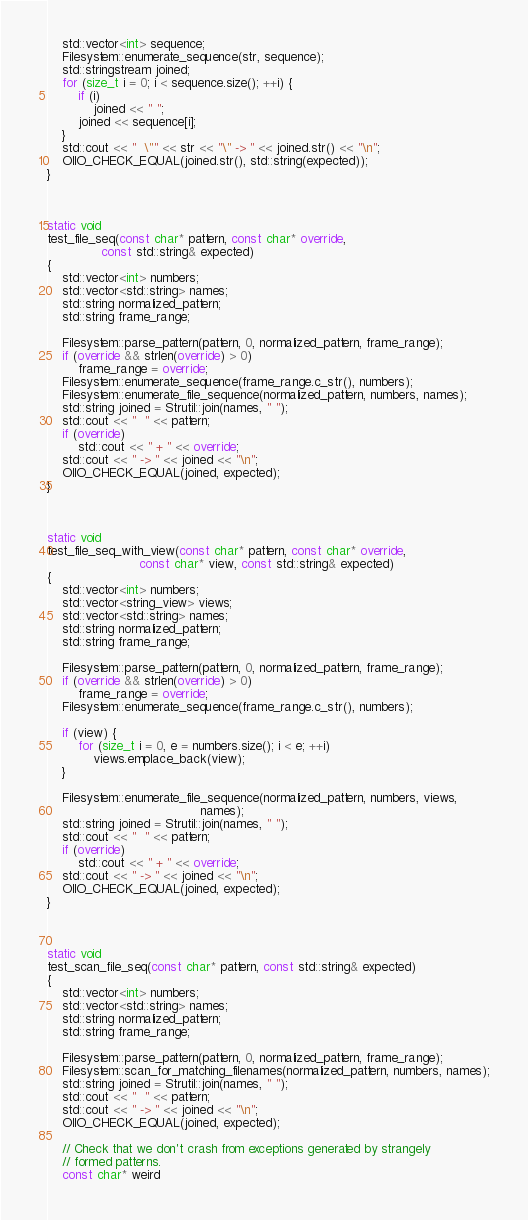Convert code to text. <code><loc_0><loc_0><loc_500><loc_500><_C++_>    std::vector<int> sequence;
    Filesystem::enumerate_sequence(str, sequence);
    std::stringstream joined;
    for (size_t i = 0; i < sequence.size(); ++i) {
        if (i)
            joined << " ";
        joined << sequence[i];
    }
    std::cout << "  \"" << str << "\" -> " << joined.str() << "\n";
    OIIO_CHECK_EQUAL(joined.str(), std::string(expected));
}



static void
test_file_seq(const char* pattern, const char* override,
              const std::string& expected)
{
    std::vector<int> numbers;
    std::vector<std::string> names;
    std::string normalized_pattern;
    std::string frame_range;

    Filesystem::parse_pattern(pattern, 0, normalized_pattern, frame_range);
    if (override && strlen(override) > 0)
        frame_range = override;
    Filesystem::enumerate_sequence(frame_range.c_str(), numbers);
    Filesystem::enumerate_file_sequence(normalized_pattern, numbers, names);
    std::string joined = Strutil::join(names, " ");
    std::cout << "  " << pattern;
    if (override)
        std::cout << " + " << override;
    std::cout << " -> " << joined << "\n";
    OIIO_CHECK_EQUAL(joined, expected);
}



static void
test_file_seq_with_view(const char* pattern, const char* override,
                        const char* view, const std::string& expected)
{
    std::vector<int> numbers;
    std::vector<string_view> views;
    std::vector<std::string> names;
    std::string normalized_pattern;
    std::string frame_range;

    Filesystem::parse_pattern(pattern, 0, normalized_pattern, frame_range);
    if (override && strlen(override) > 0)
        frame_range = override;
    Filesystem::enumerate_sequence(frame_range.c_str(), numbers);

    if (view) {
        for (size_t i = 0, e = numbers.size(); i < e; ++i)
            views.emplace_back(view);
    }

    Filesystem::enumerate_file_sequence(normalized_pattern, numbers, views,
                                        names);
    std::string joined = Strutil::join(names, " ");
    std::cout << "  " << pattern;
    if (override)
        std::cout << " + " << override;
    std::cout << " -> " << joined << "\n";
    OIIO_CHECK_EQUAL(joined, expected);
}



static void
test_scan_file_seq(const char* pattern, const std::string& expected)
{
    std::vector<int> numbers;
    std::vector<std::string> names;
    std::string normalized_pattern;
    std::string frame_range;

    Filesystem::parse_pattern(pattern, 0, normalized_pattern, frame_range);
    Filesystem::scan_for_matching_filenames(normalized_pattern, numbers, names);
    std::string joined = Strutil::join(names, " ");
    std::cout << "  " << pattern;
    std::cout << " -> " << joined << "\n";
    OIIO_CHECK_EQUAL(joined, expected);

    // Check that we don't crash from exceptions generated by strangely
    // formed patterns.
    const char* weird</code> 